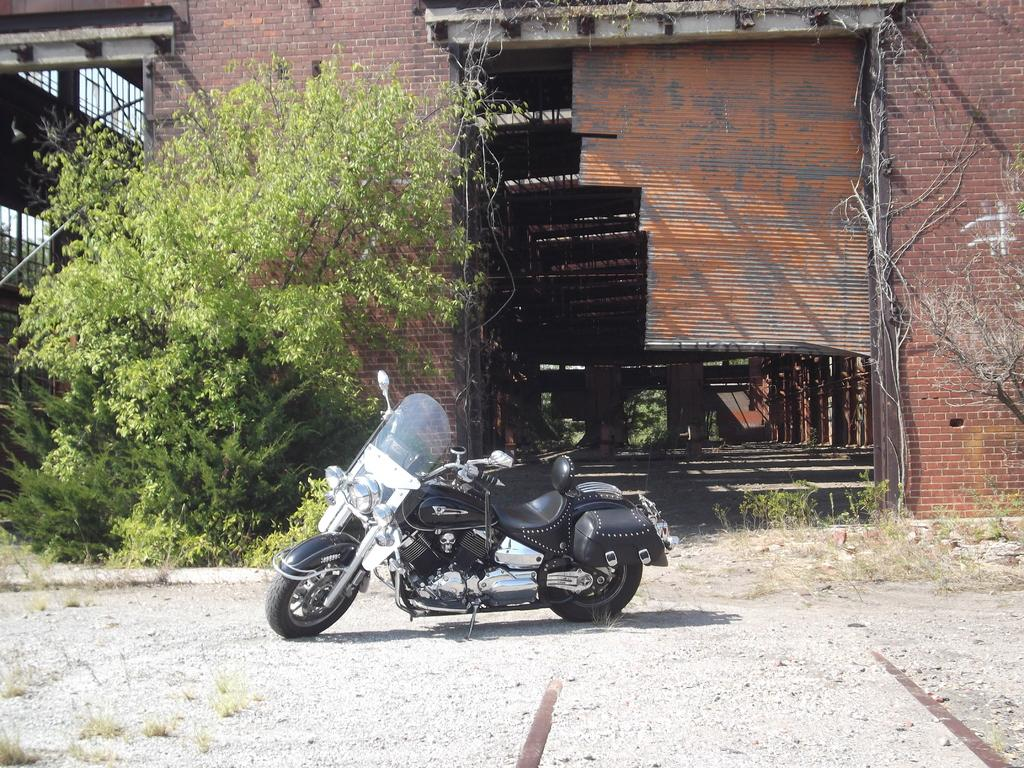What is the main subject in the center of the image? There is a bike in the center of the image. What is the position of the bike in the image? The bike is on the ground. What can be seen in the background of the image? There are trees, plants, a building, and shutters in the background of the image. What type of blade is being used to cut the arch in the image? There is no blade or arch present in the image; it features a bike on the ground with a background containing trees, plants, a building, and shutters. 